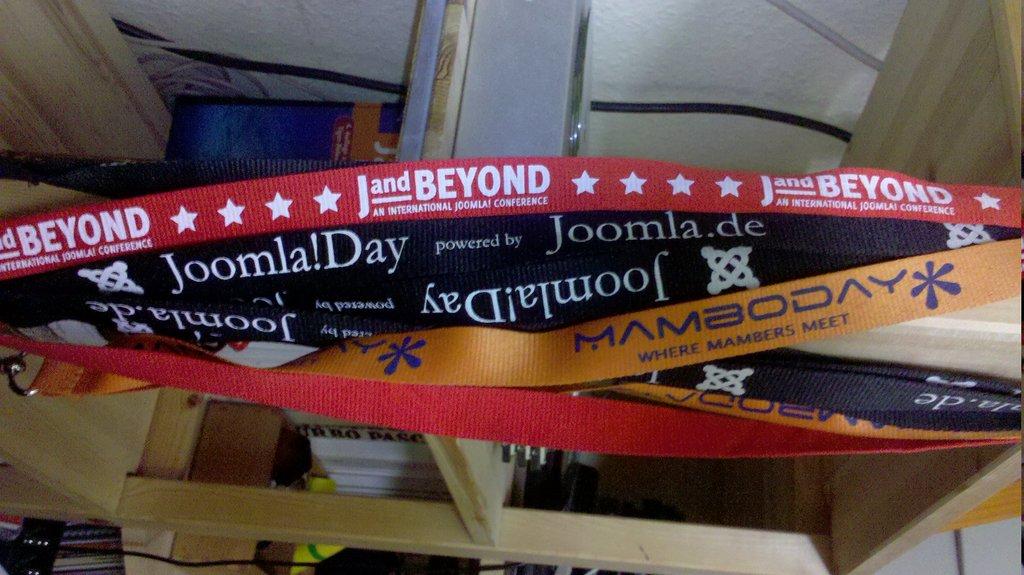What letter and,"beyond"?
Your answer should be very brief. J. 